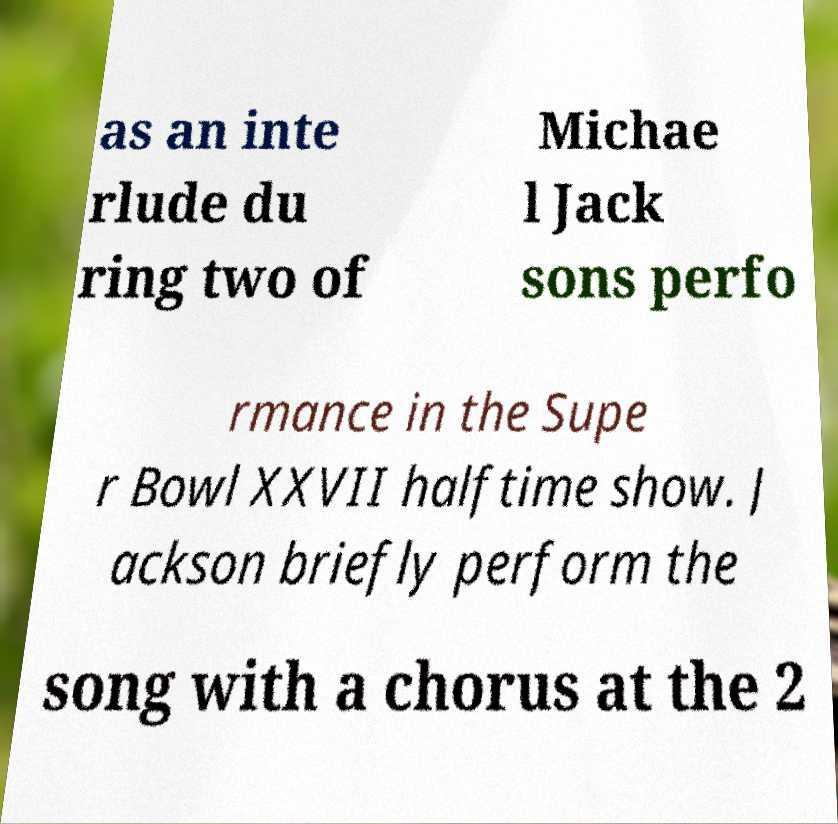Please read and relay the text visible in this image. What does it say? as an inte rlude du ring two of Michae l Jack sons perfo rmance in the Supe r Bowl XXVII halftime show. J ackson briefly perform the song with a chorus at the 2 